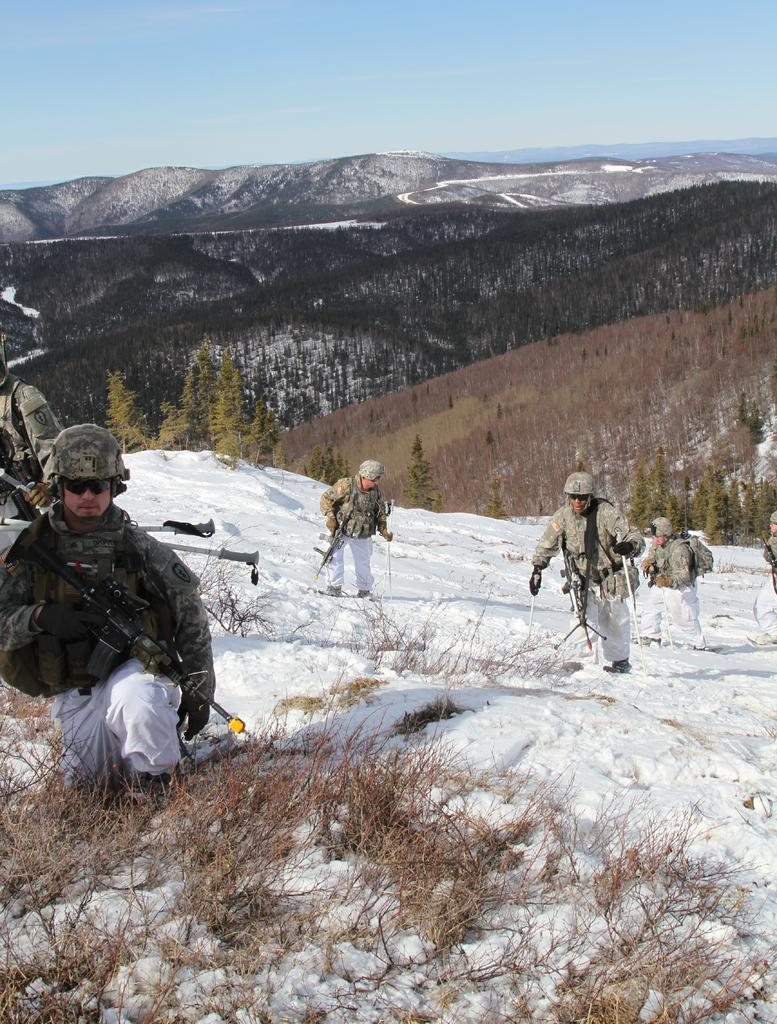Who or what is present in the image? There are people in the image. What is the weather like in the image? There is snow visible in the image, indicating a cold and likely wintery scene. What can be seen in the background of the image? There are trees and hills in the background of the image, as well as the sky. What letter is being used to build a chain in the image? There is no letter or chain present in the image. How many thumbs can be seen on the people in the image? The number of thumbs cannot be determined from the image, as only the presence of people is mentioned, not their specific body parts. 